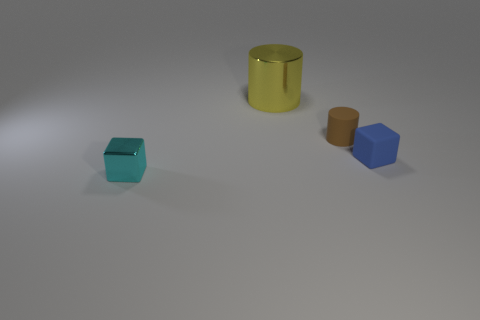Add 1 tiny gray shiny cylinders. How many objects exist? 5 Add 2 tiny brown rubber cylinders. How many tiny brown rubber cylinders are left? 3 Add 2 tiny cyan shiny blocks. How many tiny cyan shiny blocks exist? 3 Subtract 0 red cylinders. How many objects are left? 4 Subtract all rubber cylinders. Subtract all purple shiny cylinders. How many objects are left? 3 